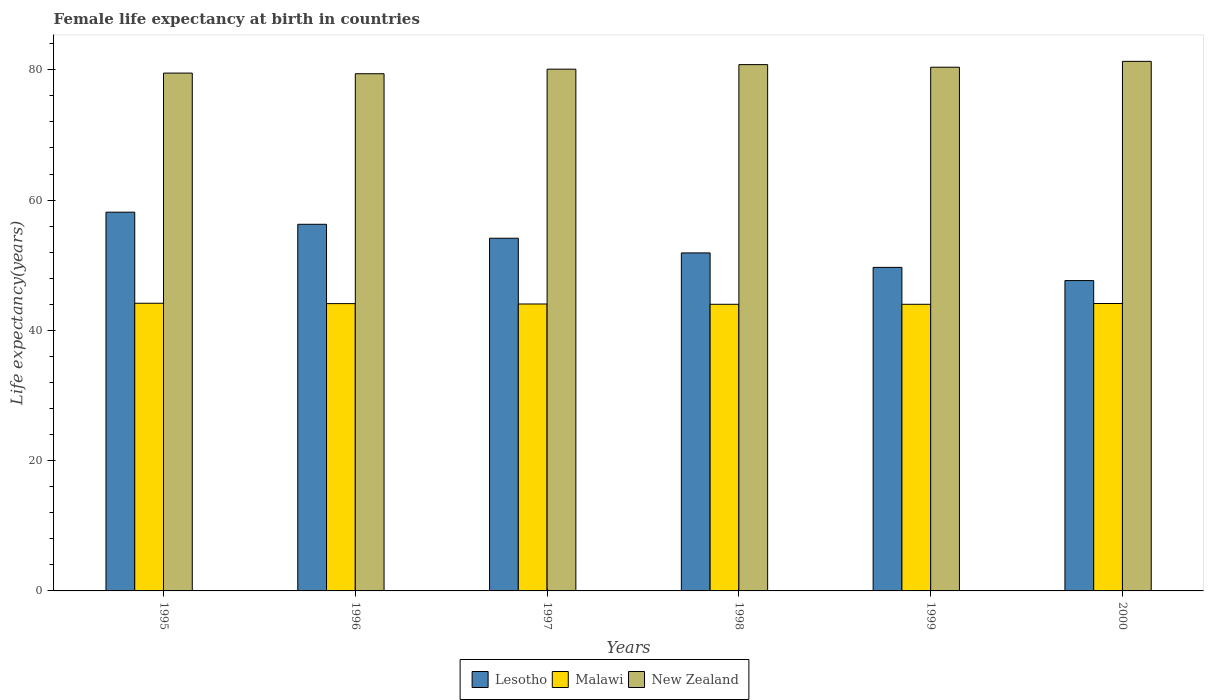Are the number of bars per tick equal to the number of legend labels?
Provide a short and direct response. Yes. How many bars are there on the 5th tick from the left?
Your response must be concise. 3. How many bars are there on the 5th tick from the right?
Your answer should be compact. 3. What is the label of the 1st group of bars from the left?
Offer a terse response. 1995. In how many cases, is the number of bars for a given year not equal to the number of legend labels?
Give a very brief answer. 0. What is the female life expectancy at birth in Lesotho in 1997?
Keep it short and to the point. 54.15. Across all years, what is the maximum female life expectancy at birth in Malawi?
Provide a short and direct response. 44.16. Across all years, what is the minimum female life expectancy at birth in New Zealand?
Your answer should be very brief. 79.4. In which year was the female life expectancy at birth in Lesotho maximum?
Your answer should be compact. 1995. In which year was the female life expectancy at birth in Malawi minimum?
Give a very brief answer. 1998. What is the total female life expectancy at birth in New Zealand in the graph?
Ensure brevity in your answer.  481.5. What is the difference between the female life expectancy at birth in Malawi in 1996 and that in 2000?
Offer a very short reply. -0.02. What is the difference between the female life expectancy at birth in Lesotho in 1999 and the female life expectancy at birth in New Zealand in 1995?
Offer a very short reply. -29.83. What is the average female life expectancy at birth in Lesotho per year?
Your answer should be very brief. 52.96. In the year 1999, what is the difference between the female life expectancy at birth in New Zealand and female life expectancy at birth in Lesotho?
Your response must be concise. 30.73. What is the ratio of the female life expectancy at birth in Malawi in 1996 to that in 2000?
Keep it short and to the point. 1. Is the female life expectancy at birth in Lesotho in 1995 less than that in 1998?
Provide a succinct answer. No. Is the difference between the female life expectancy at birth in New Zealand in 1997 and 1998 greater than the difference between the female life expectancy at birth in Lesotho in 1997 and 1998?
Your answer should be compact. No. What is the difference between the highest and the second highest female life expectancy at birth in Malawi?
Keep it short and to the point. 0.04. What is the difference between the highest and the lowest female life expectancy at birth in Malawi?
Provide a short and direct response. 0.16. What does the 2nd bar from the left in 1997 represents?
Make the answer very short. Malawi. What does the 1st bar from the right in 1995 represents?
Keep it short and to the point. New Zealand. Is it the case that in every year, the sum of the female life expectancy at birth in Lesotho and female life expectancy at birth in New Zealand is greater than the female life expectancy at birth in Malawi?
Your answer should be compact. Yes. Are the values on the major ticks of Y-axis written in scientific E-notation?
Give a very brief answer. No. Does the graph contain any zero values?
Your response must be concise. No. How many legend labels are there?
Offer a terse response. 3. What is the title of the graph?
Make the answer very short. Female life expectancy at birth in countries. Does "Pacific island small states" appear as one of the legend labels in the graph?
Offer a terse response. No. What is the label or title of the X-axis?
Offer a very short reply. Years. What is the label or title of the Y-axis?
Provide a short and direct response. Life expectancy(years). What is the Life expectancy(years) in Lesotho in 1995?
Keep it short and to the point. 58.15. What is the Life expectancy(years) in Malawi in 1995?
Make the answer very short. 44.16. What is the Life expectancy(years) of New Zealand in 1995?
Your response must be concise. 79.5. What is the Life expectancy(years) of Lesotho in 1996?
Provide a succinct answer. 56.29. What is the Life expectancy(years) in Malawi in 1996?
Provide a succinct answer. 44.11. What is the Life expectancy(years) of New Zealand in 1996?
Your response must be concise. 79.4. What is the Life expectancy(years) of Lesotho in 1997?
Your answer should be very brief. 54.15. What is the Life expectancy(years) in Malawi in 1997?
Give a very brief answer. 44.05. What is the Life expectancy(years) in New Zealand in 1997?
Provide a succinct answer. 80.1. What is the Life expectancy(years) of Lesotho in 1998?
Your answer should be compact. 51.89. What is the Life expectancy(years) of Malawi in 1998?
Give a very brief answer. 44. What is the Life expectancy(years) in New Zealand in 1998?
Provide a short and direct response. 80.8. What is the Life expectancy(years) of Lesotho in 1999?
Offer a very short reply. 49.67. What is the Life expectancy(years) of Malawi in 1999?
Provide a succinct answer. 44. What is the Life expectancy(years) in New Zealand in 1999?
Offer a terse response. 80.4. What is the Life expectancy(years) in Lesotho in 2000?
Provide a succinct answer. 47.65. What is the Life expectancy(years) in Malawi in 2000?
Make the answer very short. 44.12. What is the Life expectancy(years) of New Zealand in 2000?
Keep it short and to the point. 81.3. Across all years, what is the maximum Life expectancy(years) of Lesotho?
Keep it short and to the point. 58.15. Across all years, what is the maximum Life expectancy(years) in Malawi?
Provide a succinct answer. 44.16. Across all years, what is the maximum Life expectancy(years) in New Zealand?
Make the answer very short. 81.3. Across all years, what is the minimum Life expectancy(years) in Lesotho?
Provide a succinct answer. 47.65. Across all years, what is the minimum Life expectancy(years) in Malawi?
Provide a short and direct response. 44. Across all years, what is the minimum Life expectancy(years) in New Zealand?
Ensure brevity in your answer.  79.4. What is the total Life expectancy(years) of Lesotho in the graph?
Make the answer very short. 317.78. What is the total Life expectancy(years) of Malawi in the graph?
Your answer should be compact. 264.45. What is the total Life expectancy(years) of New Zealand in the graph?
Make the answer very short. 481.5. What is the difference between the Life expectancy(years) of Lesotho in 1995 and that in 1996?
Offer a very short reply. 1.86. What is the difference between the Life expectancy(years) of Malawi in 1995 and that in 1996?
Offer a terse response. 0.06. What is the difference between the Life expectancy(years) in New Zealand in 1995 and that in 1996?
Provide a short and direct response. 0.1. What is the difference between the Life expectancy(years) in Lesotho in 1995 and that in 1997?
Make the answer very short. 4. What is the difference between the Life expectancy(years) in Malawi in 1995 and that in 1997?
Offer a very short reply. 0.11. What is the difference between the Life expectancy(years) in Lesotho in 1995 and that in 1998?
Offer a very short reply. 6.25. What is the difference between the Life expectancy(years) in Malawi in 1995 and that in 1998?
Ensure brevity in your answer.  0.16. What is the difference between the Life expectancy(years) of Lesotho in 1995 and that in 1999?
Offer a terse response. 8.48. What is the difference between the Life expectancy(years) in Malawi in 1995 and that in 1999?
Provide a short and direct response. 0.16. What is the difference between the Life expectancy(years) in New Zealand in 1995 and that in 1999?
Keep it short and to the point. -0.9. What is the difference between the Life expectancy(years) of Lesotho in 1995 and that in 2000?
Make the answer very short. 10.5. What is the difference between the Life expectancy(years) in Malawi in 1995 and that in 2000?
Keep it short and to the point. 0.04. What is the difference between the Life expectancy(years) of New Zealand in 1995 and that in 2000?
Provide a short and direct response. -1.8. What is the difference between the Life expectancy(years) in Lesotho in 1996 and that in 1997?
Your answer should be very brief. 2.14. What is the difference between the Life expectancy(years) in Malawi in 1996 and that in 1997?
Offer a terse response. 0.06. What is the difference between the Life expectancy(years) in New Zealand in 1996 and that in 1997?
Offer a very short reply. -0.7. What is the difference between the Life expectancy(years) of Lesotho in 1996 and that in 1998?
Offer a terse response. 4.39. What is the difference between the Life expectancy(years) in Malawi in 1996 and that in 1998?
Your response must be concise. 0.1. What is the difference between the Life expectancy(years) of New Zealand in 1996 and that in 1998?
Your response must be concise. -1.4. What is the difference between the Life expectancy(years) in Lesotho in 1996 and that in 1999?
Your answer should be very brief. 6.62. What is the difference between the Life expectancy(years) of Malawi in 1996 and that in 1999?
Your answer should be very brief. 0.1. What is the difference between the Life expectancy(years) of Lesotho in 1996 and that in 2000?
Your response must be concise. 8.64. What is the difference between the Life expectancy(years) of Malawi in 1996 and that in 2000?
Ensure brevity in your answer.  -0.02. What is the difference between the Life expectancy(years) in New Zealand in 1996 and that in 2000?
Your answer should be very brief. -1.9. What is the difference between the Life expectancy(years) of Lesotho in 1997 and that in 1998?
Provide a short and direct response. 2.25. What is the difference between the Life expectancy(years) of Malawi in 1997 and that in 1998?
Your answer should be compact. 0.05. What is the difference between the Life expectancy(years) in New Zealand in 1997 and that in 1998?
Provide a short and direct response. -0.7. What is the difference between the Life expectancy(years) of Lesotho in 1997 and that in 1999?
Provide a short and direct response. 4.48. What is the difference between the Life expectancy(years) of Malawi in 1997 and that in 1999?
Your answer should be very brief. 0.05. What is the difference between the Life expectancy(years) of Lesotho in 1997 and that in 2000?
Provide a short and direct response. 6.5. What is the difference between the Life expectancy(years) of Malawi in 1997 and that in 2000?
Give a very brief answer. -0.07. What is the difference between the Life expectancy(years) of New Zealand in 1997 and that in 2000?
Provide a short and direct response. -1.2. What is the difference between the Life expectancy(years) of Lesotho in 1998 and that in 1999?
Ensure brevity in your answer.  2.22. What is the difference between the Life expectancy(years) of Malawi in 1998 and that in 1999?
Give a very brief answer. -0. What is the difference between the Life expectancy(years) in New Zealand in 1998 and that in 1999?
Provide a short and direct response. 0.4. What is the difference between the Life expectancy(years) of Lesotho in 1998 and that in 2000?
Offer a very short reply. 4.25. What is the difference between the Life expectancy(years) in Malawi in 1998 and that in 2000?
Make the answer very short. -0.12. What is the difference between the Life expectancy(years) in Lesotho in 1999 and that in 2000?
Ensure brevity in your answer.  2.02. What is the difference between the Life expectancy(years) of Malawi in 1999 and that in 2000?
Your answer should be compact. -0.12. What is the difference between the Life expectancy(years) of New Zealand in 1999 and that in 2000?
Your answer should be compact. -0.9. What is the difference between the Life expectancy(years) of Lesotho in 1995 and the Life expectancy(years) of Malawi in 1996?
Your answer should be compact. 14.04. What is the difference between the Life expectancy(years) in Lesotho in 1995 and the Life expectancy(years) in New Zealand in 1996?
Ensure brevity in your answer.  -21.25. What is the difference between the Life expectancy(years) of Malawi in 1995 and the Life expectancy(years) of New Zealand in 1996?
Provide a succinct answer. -35.24. What is the difference between the Life expectancy(years) of Lesotho in 1995 and the Life expectancy(years) of Malawi in 1997?
Keep it short and to the point. 14.1. What is the difference between the Life expectancy(years) of Lesotho in 1995 and the Life expectancy(years) of New Zealand in 1997?
Give a very brief answer. -21.95. What is the difference between the Life expectancy(years) of Malawi in 1995 and the Life expectancy(years) of New Zealand in 1997?
Make the answer very short. -35.94. What is the difference between the Life expectancy(years) in Lesotho in 1995 and the Life expectancy(years) in Malawi in 1998?
Your response must be concise. 14.14. What is the difference between the Life expectancy(years) in Lesotho in 1995 and the Life expectancy(years) in New Zealand in 1998?
Your answer should be very brief. -22.66. What is the difference between the Life expectancy(years) of Malawi in 1995 and the Life expectancy(years) of New Zealand in 1998?
Ensure brevity in your answer.  -36.64. What is the difference between the Life expectancy(years) of Lesotho in 1995 and the Life expectancy(years) of Malawi in 1999?
Your answer should be compact. 14.14. What is the difference between the Life expectancy(years) in Lesotho in 1995 and the Life expectancy(years) in New Zealand in 1999?
Your answer should be compact. -22.25. What is the difference between the Life expectancy(years) in Malawi in 1995 and the Life expectancy(years) in New Zealand in 1999?
Make the answer very short. -36.24. What is the difference between the Life expectancy(years) of Lesotho in 1995 and the Life expectancy(years) of Malawi in 2000?
Your answer should be very brief. 14.02. What is the difference between the Life expectancy(years) in Lesotho in 1995 and the Life expectancy(years) in New Zealand in 2000?
Ensure brevity in your answer.  -23.16. What is the difference between the Life expectancy(years) of Malawi in 1995 and the Life expectancy(years) of New Zealand in 2000?
Ensure brevity in your answer.  -37.14. What is the difference between the Life expectancy(years) in Lesotho in 1996 and the Life expectancy(years) in Malawi in 1997?
Your answer should be compact. 12.24. What is the difference between the Life expectancy(years) of Lesotho in 1996 and the Life expectancy(years) of New Zealand in 1997?
Make the answer very short. -23.81. What is the difference between the Life expectancy(years) in Malawi in 1996 and the Life expectancy(years) in New Zealand in 1997?
Your answer should be very brief. -35.99. What is the difference between the Life expectancy(years) in Lesotho in 1996 and the Life expectancy(years) in Malawi in 1998?
Offer a very short reply. 12.28. What is the difference between the Life expectancy(years) in Lesotho in 1996 and the Life expectancy(years) in New Zealand in 1998?
Offer a terse response. -24.51. What is the difference between the Life expectancy(years) of Malawi in 1996 and the Life expectancy(years) of New Zealand in 1998?
Offer a very short reply. -36.69. What is the difference between the Life expectancy(years) of Lesotho in 1996 and the Life expectancy(years) of Malawi in 1999?
Your response must be concise. 12.28. What is the difference between the Life expectancy(years) of Lesotho in 1996 and the Life expectancy(years) of New Zealand in 1999?
Your answer should be very brief. -24.11. What is the difference between the Life expectancy(years) of Malawi in 1996 and the Life expectancy(years) of New Zealand in 1999?
Your answer should be very brief. -36.29. What is the difference between the Life expectancy(years) in Lesotho in 1996 and the Life expectancy(years) in Malawi in 2000?
Offer a terse response. 12.16. What is the difference between the Life expectancy(years) of Lesotho in 1996 and the Life expectancy(years) of New Zealand in 2000?
Keep it short and to the point. -25.01. What is the difference between the Life expectancy(years) in Malawi in 1996 and the Life expectancy(years) in New Zealand in 2000?
Make the answer very short. -37.19. What is the difference between the Life expectancy(years) in Lesotho in 1997 and the Life expectancy(years) in Malawi in 1998?
Give a very brief answer. 10.14. What is the difference between the Life expectancy(years) in Lesotho in 1997 and the Life expectancy(years) in New Zealand in 1998?
Offer a terse response. -26.66. What is the difference between the Life expectancy(years) of Malawi in 1997 and the Life expectancy(years) of New Zealand in 1998?
Offer a very short reply. -36.75. What is the difference between the Life expectancy(years) in Lesotho in 1997 and the Life expectancy(years) in Malawi in 1999?
Your answer should be compact. 10.14. What is the difference between the Life expectancy(years) in Lesotho in 1997 and the Life expectancy(years) in New Zealand in 1999?
Provide a succinct answer. -26.25. What is the difference between the Life expectancy(years) of Malawi in 1997 and the Life expectancy(years) of New Zealand in 1999?
Your answer should be compact. -36.35. What is the difference between the Life expectancy(years) of Lesotho in 1997 and the Life expectancy(years) of Malawi in 2000?
Keep it short and to the point. 10.02. What is the difference between the Life expectancy(years) of Lesotho in 1997 and the Life expectancy(years) of New Zealand in 2000?
Give a very brief answer. -27.16. What is the difference between the Life expectancy(years) in Malawi in 1997 and the Life expectancy(years) in New Zealand in 2000?
Give a very brief answer. -37.25. What is the difference between the Life expectancy(years) in Lesotho in 1998 and the Life expectancy(years) in Malawi in 1999?
Your answer should be compact. 7.89. What is the difference between the Life expectancy(years) in Lesotho in 1998 and the Life expectancy(years) in New Zealand in 1999?
Your answer should be very brief. -28.51. What is the difference between the Life expectancy(years) in Malawi in 1998 and the Life expectancy(years) in New Zealand in 1999?
Provide a succinct answer. -36.4. What is the difference between the Life expectancy(years) of Lesotho in 1998 and the Life expectancy(years) of Malawi in 2000?
Keep it short and to the point. 7.77. What is the difference between the Life expectancy(years) of Lesotho in 1998 and the Life expectancy(years) of New Zealand in 2000?
Make the answer very short. -29.41. What is the difference between the Life expectancy(years) of Malawi in 1998 and the Life expectancy(years) of New Zealand in 2000?
Provide a short and direct response. -37.3. What is the difference between the Life expectancy(years) of Lesotho in 1999 and the Life expectancy(years) of Malawi in 2000?
Make the answer very short. 5.54. What is the difference between the Life expectancy(years) of Lesotho in 1999 and the Life expectancy(years) of New Zealand in 2000?
Offer a very short reply. -31.63. What is the difference between the Life expectancy(years) in Malawi in 1999 and the Life expectancy(years) in New Zealand in 2000?
Make the answer very short. -37.3. What is the average Life expectancy(years) in Lesotho per year?
Give a very brief answer. 52.96. What is the average Life expectancy(years) of Malawi per year?
Provide a short and direct response. 44.08. What is the average Life expectancy(years) of New Zealand per year?
Give a very brief answer. 80.25. In the year 1995, what is the difference between the Life expectancy(years) in Lesotho and Life expectancy(years) in Malawi?
Provide a short and direct response. 13.98. In the year 1995, what is the difference between the Life expectancy(years) of Lesotho and Life expectancy(years) of New Zealand?
Your response must be concise. -21.36. In the year 1995, what is the difference between the Life expectancy(years) in Malawi and Life expectancy(years) in New Zealand?
Provide a short and direct response. -35.34. In the year 1996, what is the difference between the Life expectancy(years) in Lesotho and Life expectancy(years) in Malawi?
Make the answer very short. 12.18. In the year 1996, what is the difference between the Life expectancy(years) of Lesotho and Life expectancy(years) of New Zealand?
Give a very brief answer. -23.11. In the year 1996, what is the difference between the Life expectancy(years) in Malawi and Life expectancy(years) in New Zealand?
Give a very brief answer. -35.29. In the year 1997, what is the difference between the Life expectancy(years) in Lesotho and Life expectancy(years) in Malawi?
Make the answer very short. 10.1. In the year 1997, what is the difference between the Life expectancy(years) of Lesotho and Life expectancy(years) of New Zealand?
Ensure brevity in your answer.  -25.95. In the year 1997, what is the difference between the Life expectancy(years) in Malawi and Life expectancy(years) in New Zealand?
Make the answer very short. -36.05. In the year 1998, what is the difference between the Life expectancy(years) in Lesotho and Life expectancy(years) in Malawi?
Your answer should be very brief. 7.89. In the year 1998, what is the difference between the Life expectancy(years) in Lesotho and Life expectancy(years) in New Zealand?
Provide a succinct answer. -28.91. In the year 1998, what is the difference between the Life expectancy(years) of Malawi and Life expectancy(years) of New Zealand?
Ensure brevity in your answer.  -36.8. In the year 1999, what is the difference between the Life expectancy(years) of Lesotho and Life expectancy(years) of Malawi?
Give a very brief answer. 5.67. In the year 1999, what is the difference between the Life expectancy(years) in Lesotho and Life expectancy(years) in New Zealand?
Your answer should be very brief. -30.73. In the year 1999, what is the difference between the Life expectancy(years) of Malawi and Life expectancy(years) of New Zealand?
Give a very brief answer. -36.4. In the year 2000, what is the difference between the Life expectancy(years) of Lesotho and Life expectancy(years) of Malawi?
Your answer should be very brief. 3.52. In the year 2000, what is the difference between the Life expectancy(years) in Lesotho and Life expectancy(years) in New Zealand?
Offer a very short reply. -33.65. In the year 2000, what is the difference between the Life expectancy(years) of Malawi and Life expectancy(years) of New Zealand?
Your answer should be compact. -37.17. What is the ratio of the Life expectancy(years) of Lesotho in 1995 to that in 1996?
Make the answer very short. 1.03. What is the ratio of the Life expectancy(years) in Lesotho in 1995 to that in 1997?
Offer a very short reply. 1.07. What is the ratio of the Life expectancy(years) in Malawi in 1995 to that in 1997?
Your response must be concise. 1. What is the ratio of the Life expectancy(years) in Lesotho in 1995 to that in 1998?
Make the answer very short. 1.12. What is the ratio of the Life expectancy(years) in Malawi in 1995 to that in 1998?
Keep it short and to the point. 1. What is the ratio of the Life expectancy(years) in New Zealand in 1995 to that in 1998?
Ensure brevity in your answer.  0.98. What is the ratio of the Life expectancy(years) in Lesotho in 1995 to that in 1999?
Ensure brevity in your answer.  1.17. What is the ratio of the Life expectancy(years) in New Zealand in 1995 to that in 1999?
Provide a succinct answer. 0.99. What is the ratio of the Life expectancy(years) of Lesotho in 1995 to that in 2000?
Provide a succinct answer. 1.22. What is the ratio of the Life expectancy(years) in Malawi in 1995 to that in 2000?
Provide a short and direct response. 1. What is the ratio of the Life expectancy(years) in New Zealand in 1995 to that in 2000?
Keep it short and to the point. 0.98. What is the ratio of the Life expectancy(years) in Lesotho in 1996 to that in 1997?
Offer a very short reply. 1.04. What is the ratio of the Life expectancy(years) in Lesotho in 1996 to that in 1998?
Offer a very short reply. 1.08. What is the ratio of the Life expectancy(years) of New Zealand in 1996 to that in 1998?
Your answer should be very brief. 0.98. What is the ratio of the Life expectancy(years) of Lesotho in 1996 to that in 1999?
Make the answer very short. 1.13. What is the ratio of the Life expectancy(years) in Malawi in 1996 to that in 1999?
Provide a succinct answer. 1. What is the ratio of the Life expectancy(years) of New Zealand in 1996 to that in 1999?
Provide a succinct answer. 0.99. What is the ratio of the Life expectancy(years) in Lesotho in 1996 to that in 2000?
Ensure brevity in your answer.  1.18. What is the ratio of the Life expectancy(years) in New Zealand in 1996 to that in 2000?
Provide a short and direct response. 0.98. What is the ratio of the Life expectancy(years) in Lesotho in 1997 to that in 1998?
Your answer should be compact. 1.04. What is the ratio of the Life expectancy(years) of Malawi in 1997 to that in 1998?
Ensure brevity in your answer.  1. What is the ratio of the Life expectancy(years) in Lesotho in 1997 to that in 1999?
Your answer should be very brief. 1.09. What is the ratio of the Life expectancy(years) in New Zealand in 1997 to that in 1999?
Make the answer very short. 1. What is the ratio of the Life expectancy(years) in Lesotho in 1997 to that in 2000?
Your answer should be compact. 1.14. What is the ratio of the Life expectancy(years) of New Zealand in 1997 to that in 2000?
Make the answer very short. 0.99. What is the ratio of the Life expectancy(years) in Lesotho in 1998 to that in 1999?
Make the answer very short. 1.04. What is the ratio of the Life expectancy(years) of Lesotho in 1998 to that in 2000?
Make the answer very short. 1.09. What is the ratio of the Life expectancy(years) in Lesotho in 1999 to that in 2000?
Offer a terse response. 1.04. What is the ratio of the Life expectancy(years) of Malawi in 1999 to that in 2000?
Ensure brevity in your answer.  1. What is the ratio of the Life expectancy(years) in New Zealand in 1999 to that in 2000?
Your answer should be compact. 0.99. What is the difference between the highest and the second highest Life expectancy(years) in Lesotho?
Make the answer very short. 1.86. What is the difference between the highest and the second highest Life expectancy(years) in Malawi?
Give a very brief answer. 0.04. What is the difference between the highest and the lowest Life expectancy(years) in Lesotho?
Your answer should be very brief. 10.5. What is the difference between the highest and the lowest Life expectancy(years) of Malawi?
Keep it short and to the point. 0.16. What is the difference between the highest and the lowest Life expectancy(years) in New Zealand?
Keep it short and to the point. 1.9. 